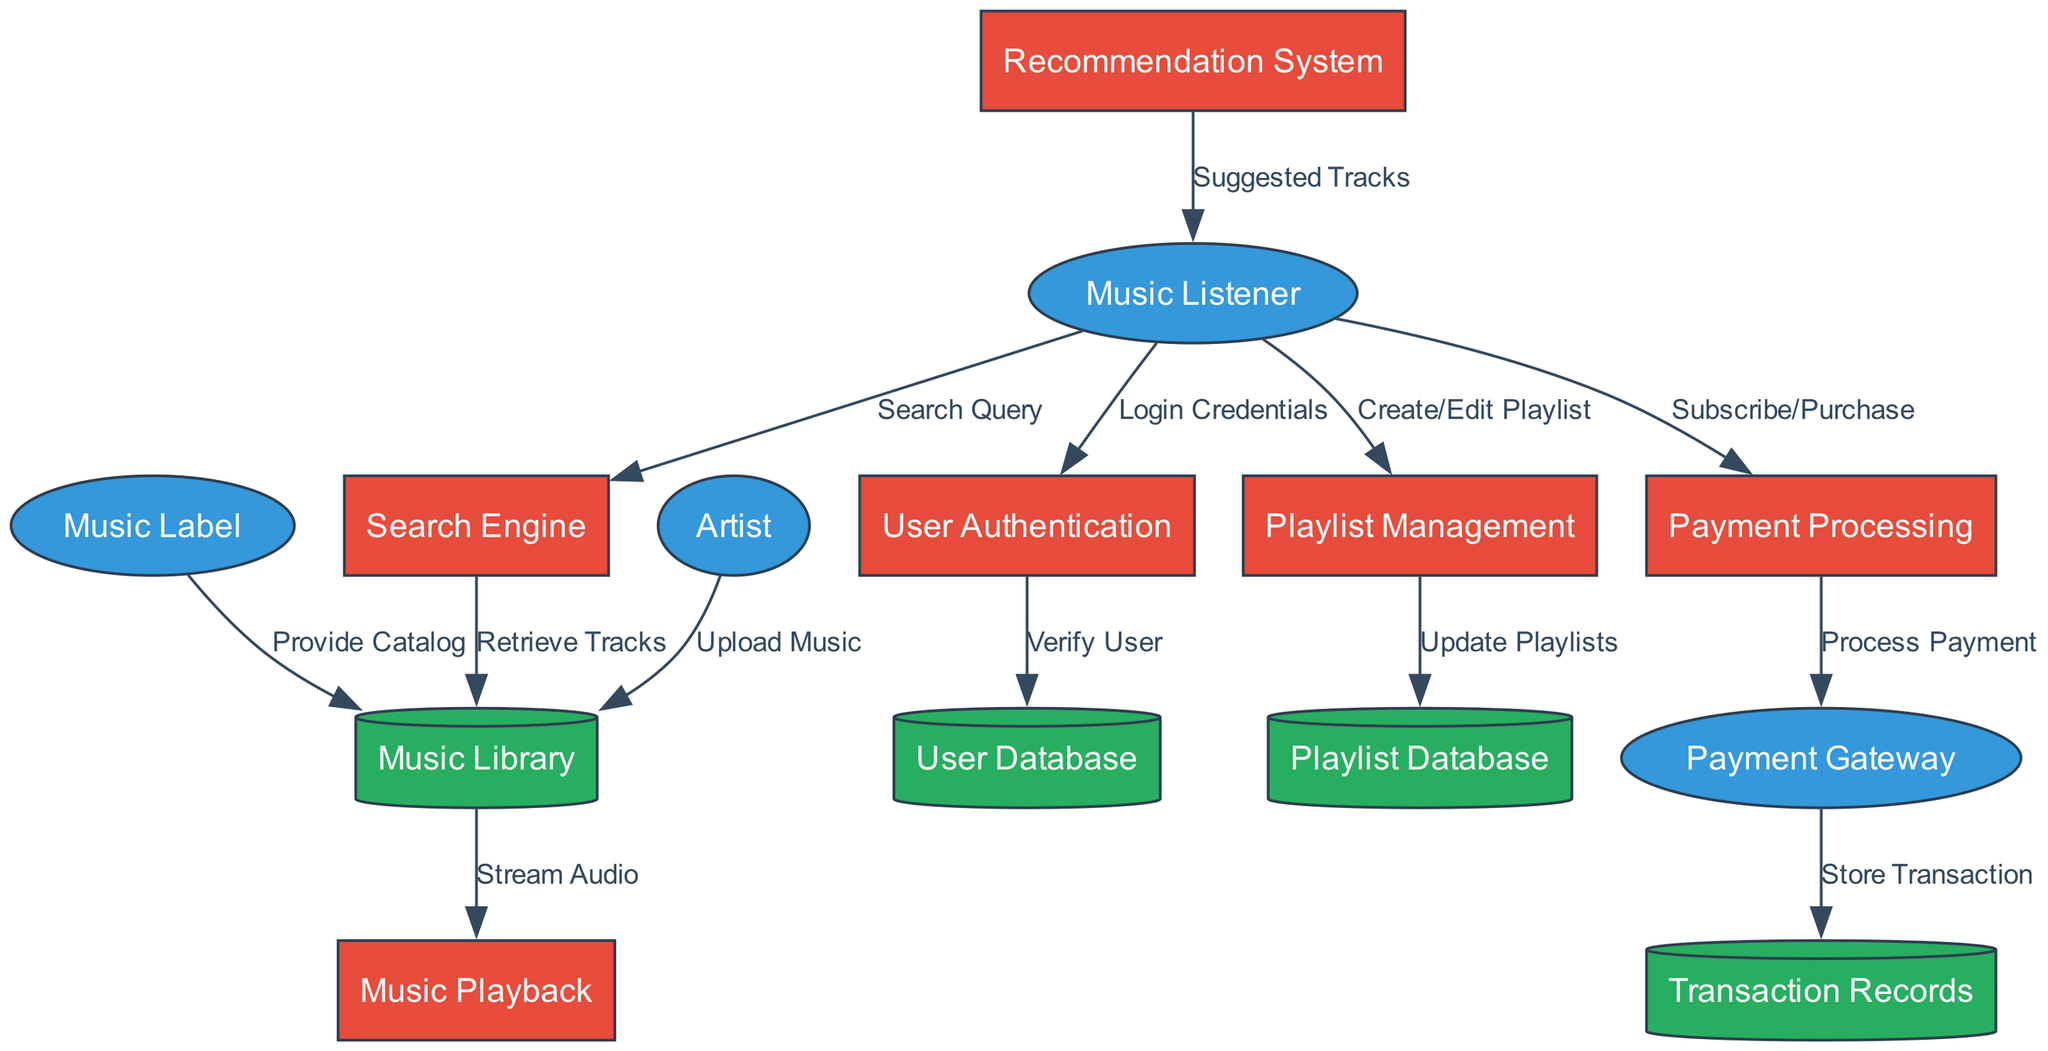What is the total number of external entities in the diagram? The diagram lists four external entities: Music Listener, Artist, Music Label, and Payment Gateway. Counting these gives a total of four.
Answer: 4 Which process handles user logins? The process responsible for user logins is User Authentication, which receives Login Credentials from Music Listener.
Answer: User Authentication How many data flows connect the Music Listener to other components? The Music Listener has three data flows: to User Authentication (Login Credentials), to Search Engine (Search Query), and to Playlist Management (Create/Edit Playlist). Counting these gives a total of three.
Answer: 3 What type of data store is used for storing user information? User information is stored in the User Database, identified as a data store in the diagram.
Answer: User Database What data flow occurs between Payment Processing and Payment Gateway? The data flow between Payment Processing and Payment Gateway is labeled Process Payment, indicating the transaction processing.
Answer: Process Payment Which entity provides the music catalog to the Music Library? The Music Label is the entity that provides the catalog to the Music Library, as indicated in the diagram.
Answer: Music Label How many processes in the diagram involve Music Listener? There are four processes involving the Music Listener: User Authentication, Music Playback, Playlist Management, and Recommendation System. Counting these gives a total of four.
Answer: 4 What is the purpose of the Payment Processing process? The purpose of the Payment Processing process is to handle Subscribe/Purchase actions from the Music Listener and subsequently Process Payment with the Payment Gateway.
Answer: Process payments Which process sends Suggested Tracks to the Music Listener? The process that sends Suggested Tracks to the Music Listener is the Recommendation System, as depicted in the data flows.
Answer: Recommendation System 